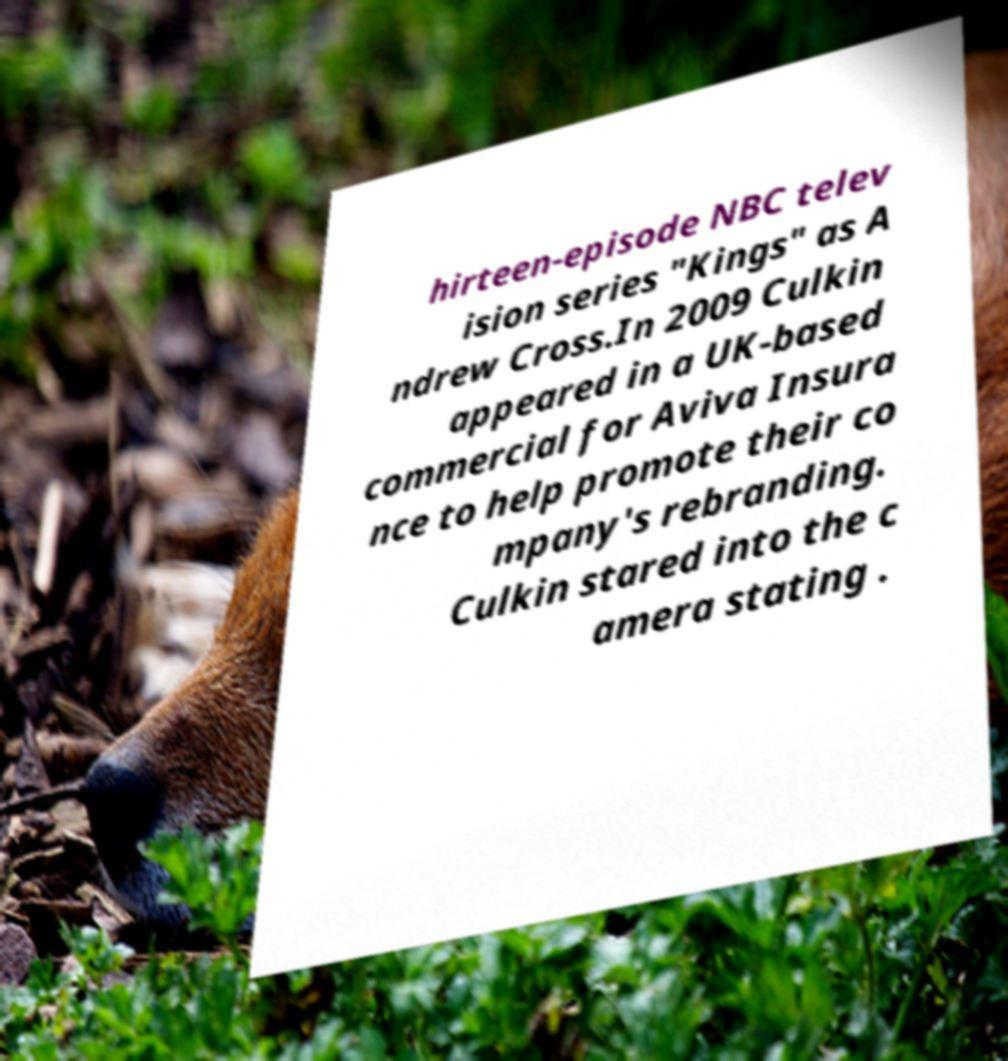For documentation purposes, I need the text within this image transcribed. Could you provide that? hirteen-episode NBC telev ision series "Kings" as A ndrew Cross.In 2009 Culkin appeared in a UK-based commercial for Aviva Insura nce to help promote their co mpany's rebranding. Culkin stared into the c amera stating . 